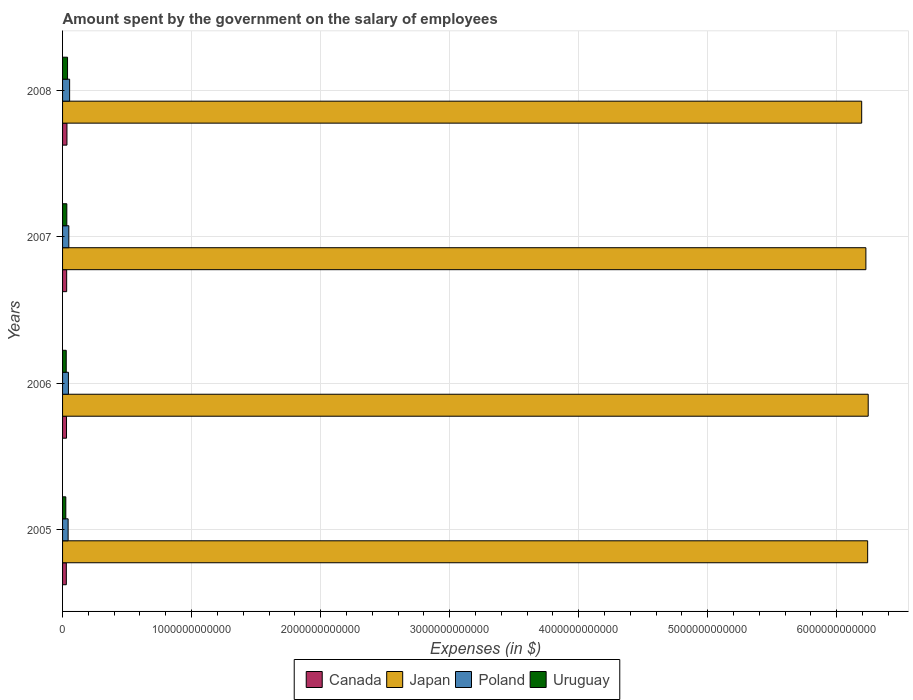How many different coloured bars are there?
Your response must be concise. 4. How many groups of bars are there?
Offer a very short reply. 4. Are the number of bars per tick equal to the number of legend labels?
Provide a succinct answer. Yes. Are the number of bars on each tick of the Y-axis equal?
Your answer should be compact. Yes. How many bars are there on the 3rd tick from the top?
Keep it short and to the point. 4. How many bars are there on the 4th tick from the bottom?
Give a very brief answer. 4. In how many cases, is the number of bars for a given year not equal to the number of legend labels?
Your answer should be compact. 0. What is the amount spent on the salary of employees by the government in Uruguay in 2006?
Offer a very short reply. 2.84e+1. Across all years, what is the maximum amount spent on the salary of employees by the government in Japan?
Your answer should be very brief. 6.24e+12. Across all years, what is the minimum amount spent on the salary of employees by the government in Canada?
Give a very brief answer. 2.92e+1. What is the total amount spent on the salary of employees by the government in Japan in the graph?
Give a very brief answer. 2.49e+13. What is the difference between the amount spent on the salary of employees by the government in Uruguay in 2005 and that in 2008?
Your answer should be very brief. -1.33e+1. What is the difference between the amount spent on the salary of employees by the government in Canada in 2005 and the amount spent on the salary of employees by the government in Japan in 2008?
Provide a succinct answer. -6.16e+12. What is the average amount spent on the salary of employees by the government in Uruguay per year?
Your answer should be compact. 3.13e+1. In the year 2006, what is the difference between the amount spent on the salary of employees by the government in Poland and amount spent on the salary of employees by the government in Canada?
Your answer should be very brief. 1.48e+1. In how many years, is the amount spent on the salary of employees by the government in Uruguay greater than 2600000000000 $?
Ensure brevity in your answer.  0. What is the ratio of the amount spent on the salary of employees by the government in Canada in 2006 to that in 2007?
Offer a terse response. 0.96. What is the difference between the highest and the second highest amount spent on the salary of employees by the government in Japan?
Make the answer very short. 4.30e+09. What is the difference between the highest and the lowest amount spent on the salary of employees by the government in Japan?
Your answer should be compact. 5.06e+1. What does the 3rd bar from the top in 2007 represents?
Ensure brevity in your answer.  Japan. What does the 4th bar from the bottom in 2005 represents?
Your response must be concise. Uruguay. Are all the bars in the graph horizontal?
Offer a terse response. Yes. How many years are there in the graph?
Your response must be concise. 4. What is the difference between two consecutive major ticks on the X-axis?
Provide a short and direct response. 1.00e+12. Are the values on the major ticks of X-axis written in scientific E-notation?
Offer a terse response. No. How are the legend labels stacked?
Keep it short and to the point. Horizontal. What is the title of the graph?
Offer a terse response. Amount spent by the government on the salary of employees. What is the label or title of the X-axis?
Give a very brief answer. Expenses (in $). What is the Expenses (in $) of Canada in 2005?
Provide a short and direct response. 2.92e+1. What is the Expenses (in $) in Japan in 2005?
Offer a terse response. 6.24e+12. What is the Expenses (in $) in Poland in 2005?
Your answer should be very brief. 4.31e+1. What is the Expenses (in $) in Uruguay in 2005?
Your answer should be very brief. 2.52e+1. What is the Expenses (in $) of Canada in 2006?
Provide a short and direct response. 3.06e+1. What is the Expenses (in $) in Japan in 2006?
Make the answer very short. 6.24e+12. What is the Expenses (in $) in Poland in 2006?
Keep it short and to the point. 4.54e+1. What is the Expenses (in $) in Uruguay in 2006?
Your response must be concise. 2.84e+1. What is the Expenses (in $) of Canada in 2007?
Provide a succinct answer. 3.18e+1. What is the Expenses (in $) in Japan in 2007?
Ensure brevity in your answer.  6.23e+12. What is the Expenses (in $) in Poland in 2007?
Ensure brevity in your answer.  4.85e+1. What is the Expenses (in $) of Uruguay in 2007?
Your answer should be very brief. 3.30e+1. What is the Expenses (in $) of Canada in 2008?
Your response must be concise. 3.40e+1. What is the Expenses (in $) of Japan in 2008?
Make the answer very short. 6.19e+12. What is the Expenses (in $) of Poland in 2008?
Your answer should be compact. 5.47e+1. What is the Expenses (in $) of Uruguay in 2008?
Provide a short and direct response. 3.86e+1. Across all years, what is the maximum Expenses (in $) of Canada?
Offer a very short reply. 3.40e+1. Across all years, what is the maximum Expenses (in $) in Japan?
Your response must be concise. 6.24e+12. Across all years, what is the maximum Expenses (in $) of Poland?
Keep it short and to the point. 5.47e+1. Across all years, what is the maximum Expenses (in $) in Uruguay?
Ensure brevity in your answer.  3.86e+1. Across all years, what is the minimum Expenses (in $) in Canada?
Keep it short and to the point. 2.92e+1. Across all years, what is the minimum Expenses (in $) of Japan?
Make the answer very short. 6.19e+12. Across all years, what is the minimum Expenses (in $) of Poland?
Provide a short and direct response. 4.31e+1. Across all years, what is the minimum Expenses (in $) of Uruguay?
Ensure brevity in your answer.  2.52e+1. What is the total Expenses (in $) of Canada in the graph?
Offer a terse response. 1.26e+11. What is the total Expenses (in $) in Japan in the graph?
Your answer should be very brief. 2.49e+13. What is the total Expenses (in $) in Poland in the graph?
Your response must be concise. 1.92e+11. What is the total Expenses (in $) in Uruguay in the graph?
Provide a short and direct response. 1.25e+11. What is the difference between the Expenses (in $) in Canada in 2005 and that in 2006?
Offer a very short reply. -1.36e+09. What is the difference between the Expenses (in $) of Japan in 2005 and that in 2006?
Offer a very short reply. -4.30e+09. What is the difference between the Expenses (in $) of Poland in 2005 and that in 2006?
Make the answer very short. -2.33e+09. What is the difference between the Expenses (in $) of Uruguay in 2005 and that in 2006?
Provide a succinct answer. -3.24e+09. What is the difference between the Expenses (in $) of Canada in 2005 and that in 2007?
Keep it short and to the point. -2.63e+09. What is the difference between the Expenses (in $) of Japan in 2005 and that in 2007?
Offer a terse response. 1.37e+1. What is the difference between the Expenses (in $) in Poland in 2005 and that in 2007?
Ensure brevity in your answer.  -5.40e+09. What is the difference between the Expenses (in $) of Uruguay in 2005 and that in 2007?
Provide a short and direct response. -7.79e+09. What is the difference between the Expenses (in $) in Canada in 2005 and that in 2008?
Your response must be concise. -4.74e+09. What is the difference between the Expenses (in $) of Japan in 2005 and that in 2008?
Keep it short and to the point. 4.63e+1. What is the difference between the Expenses (in $) in Poland in 2005 and that in 2008?
Your answer should be very brief. -1.16e+1. What is the difference between the Expenses (in $) of Uruguay in 2005 and that in 2008?
Keep it short and to the point. -1.33e+1. What is the difference between the Expenses (in $) of Canada in 2006 and that in 2007?
Provide a short and direct response. -1.27e+09. What is the difference between the Expenses (in $) of Japan in 2006 and that in 2007?
Your answer should be very brief. 1.80e+1. What is the difference between the Expenses (in $) of Poland in 2006 and that in 2007?
Give a very brief answer. -3.07e+09. What is the difference between the Expenses (in $) in Uruguay in 2006 and that in 2007?
Provide a short and direct response. -4.56e+09. What is the difference between the Expenses (in $) in Canada in 2006 and that in 2008?
Ensure brevity in your answer.  -3.38e+09. What is the difference between the Expenses (in $) of Japan in 2006 and that in 2008?
Your response must be concise. 5.06e+1. What is the difference between the Expenses (in $) in Poland in 2006 and that in 2008?
Offer a very short reply. -9.30e+09. What is the difference between the Expenses (in $) in Uruguay in 2006 and that in 2008?
Keep it short and to the point. -1.01e+1. What is the difference between the Expenses (in $) of Canada in 2007 and that in 2008?
Provide a short and direct response. -2.11e+09. What is the difference between the Expenses (in $) of Japan in 2007 and that in 2008?
Provide a short and direct response. 3.26e+1. What is the difference between the Expenses (in $) in Poland in 2007 and that in 2008?
Your answer should be compact. -6.23e+09. What is the difference between the Expenses (in $) in Uruguay in 2007 and that in 2008?
Provide a succinct answer. -5.55e+09. What is the difference between the Expenses (in $) of Canada in 2005 and the Expenses (in $) of Japan in 2006?
Your response must be concise. -6.21e+12. What is the difference between the Expenses (in $) in Canada in 2005 and the Expenses (in $) in Poland in 2006?
Provide a short and direct response. -1.62e+1. What is the difference between the Expenses (in $) of Canada in 2005 and the Expenses (in $) of Uruguay in 2006?
Provide a succinct answer. 7.65e+08. What is the difference between the Expenses (in $) of Japan in 2005 and the Expenses (in $) of Poland in 2006?
Your answer should be compact. 6.19e+12. What is the difference between the Expenses (in $) in Japan in 2005 and the Expenses (in $) in Uruguay in 2006?
Give a very brief answer. 6.21e+12. What is the difference between the Expenses (in $) in Poland in 2005 and the Expenses (in $) in Uruguay in 2006?
Provide a succinct answer. 1.46e+1. What is the difference between the Expenses (in $) in Canada in 2005 and the Expenses (in $) in Japan in 2007?
Your answer should be very brief. -6.20e+12. What is the difference between the Expenses (in $) of Canada in 2005 and the Expenses (in $) of Poland in 2007?
Provide a succinct answer. -1.93e+1. What is the difference between the Expenses (in $) in Canada in 2005 and the Expenses (in $) in Uruguay in 2007?
Make the answer very short. -3.79e+09. What is the difference between the Expenses (in $) of Japan in 2005 and the Expenses (in $) of Poland in 2007?
Your answer should be compact. 6.19e+12. What is the difference between the Expenses (in $) in Japan in 2005 and the Expenses (in $) in Uruguay in 2007?
Your response must be concise. 6.21e+12. What is the difference between the Expenses (in $) in Poland in 2005 and the Expenses (in $) in Uruguay in 2007?
Provide a short and direct response. 1.01e+1. What is the difference between the Expenses (in $) in Canada in 2005 and the Expenses (in $) in Japan in 2008?
Ensure brevity in your answer.  -6.16e+12. What is the difference between the Expenses (in $) in Canada in 2005 and the Expenses (in $) in Poland in 2008?
Offer a very short reply. -2.55e+1. What is the difference between the Expenses (in $) of Canada in 2005 and the Expenses (in $) of Uruguay in 2008?
Ensure brevity in your answer.  -9.35e+09. What is the difference between the Expenses (in $) of Japan in 2005 and the Expenses (in $) of Poland in 2008?
Offer a very short reply. 6.18e+12. What is the difference between the Expenses (in $) of Japan in 2005 and the Expenses (in $) of Uruguay in 2008?
Provide a short and direct response. 6.20e+12. What is the difference between the Expenses (in $) in Poland in 2005 and the Expenses (in $) in Uruguay in 2008?
Ensure brevity in your answer.  4.53e+09. What is the difference between the Expenses (in $) in Canada in 2006 and the Expenses (in $) in Japan in 2007?
Give a very brief answer. -6.20e+12. What is the difference between the Expenses (in $) of Canada in 2006 and the Expenses (in $) of Poland in 2007?
Ensure brevity in your answer.  -1.79e+1. What is the difference between the Expenses (in $) of Canada in 2006 and the Expenses (in $) of Uruguay in 2007?
Your response must be concise. -2.43e+09. What is the difference between the Expenses (in $) of Japan in 2006 and the Expenses (in $) of Poland in 2007?
Provide a short and direct response. 6.20e+12. What is the difference between the Expenses (in $) in Japan in 2006 and the Expenses (in $) in Uruguay in 2007?
Ensure brevity in your answer.  6.21e+12. What is the difference between the Expenses (in $) of Poland in 2006 and the Expenses (in $) of Uruguay in 2007?
Provide a short and direct response. 1.24e+1. What is the difference between the Expenses (in $) of Canada in 2006 and the Expenses (in $) of Japan in 2008?
Keep it short and to the point. -6.16e+12. What is the difference between the Expenses (in $) of Canada in 2006 and the Expenses (in $) of Poland in 2008?
Your answer should be very brief. -2.41e+1. What is the difference between the Expenses (in $) of Canada in 2006 and the Expenses (in $) of Uruguay in 2008?
Your answer should be very brief. -7.99e+09. What is the difference between the Expenses (in $) in Japan in 2006 and the Expenses (in $) in Poland in 2008?
Offer a very short reply. 6.19e+12. What is the difference between the Expenses (in $) in Japan in 2006 and the Expenses (in $) in Uruguay in 2008?
Your response must be concise. 6.21e+12. What is the difference between the Expenses (in $) in Poland in 2006 and the Expenses (in $) in Uruguay in 2008?
Provide a succinct answer. 6.86e+09. What is the difference between the Expenses (in $) in Canada in 2007 and the Expenses (in $) in Japan in 2008?
Keep it short and to the point. -6.16e+12. What is the difference between the Expenses (in $) of Canada in 2007 and the Expenses (in $) of Poland in 2008?
Offer a terse response. -2.29e+1. What is the difference between the Expenses (in $) in Canada in 2007 and the Expenses (in $) in Uruguay in 2008?
Keep it short and to the point. -6.71e+09. What is the difference between the Expenses (in $) in Japan in 2007 and the Expenses (in $) in Poland in 2008?
Make the answer very short. 6.17e+12. What is the difference between the Expenses (in $) of Japan in 2007 and the Expenses (in $) of Uruguay in 2008?
Offer a terse response. 6.19e+12. What is the difference between the Expenses (in $) in Poland in 2007 and the Expenses (in $) in Uruguay in 2008?
Offer a very short reply. 9.93e+09. What is the average Expenses (in $) of Canada per year?
Offer a very short reply. 3.14e+1. What is the average Expenses (in $) in Japan per year?
Your response must be concise. 6.23e+12. What is the average Expenses (in $) in Poland per year?
Offer a very short reply. 4.79e+1. What is the average Expenses (in $) in Uruguay per year?
Ensure brevity in your answer.  3.13e+1. In the year 2005, what is the difference between the Expenses (in $) in Canada and Expenses (in $) in Japan?
Offer a terse response. -6.21e+12. In the year 2005, what is the difference between the Expenses (in $) of Canada and Expenses (in $) of Poland?
Ensure brevity in your answer.  -1.39e+1. In the year 2005, what is the difference between the Expenses (in $) of Canada and Expenses (in $) of Uruguay?
Your answer should be compact. 4.00e+09. In the year 2005, what is the difference between the Expenses (in $) in Japan and Expenses (in $) in Poland?
Make the answer very short. 6.20e+12. In the year 2005, what is the difference between the Expenses (in $) in Japan and Expenses (in $) in Uruguay?
Your response must be concise. 6.21e+12. In the year 2005, what is the difference between the Expenses (in $) of Poland and Expenses (in $) of Uruguay?
Your response must be concise. 1.79e+1. In the year 2006, what is the difference between the Expenses (in $) of Canada and Expenses (in $) of Japan?
Your response must be concise. -6.21e+12. In the year 2006, what is the difference between the Expenses (in $) in Canada and Expenses (in $) in Poland?
Provide a succinct answer. -1.48e+1. In the year 2006, what is the difference between the Expenses (in $) in Canada and Expenses (in $) in Uruguay?
Your answer should be very brief. 2.12e+09. In the year 2006, what is the difference between the Expenses (in $) of Japan and Expenses (in $) of Poland?
Give a very brief answer. 6.20e+12. In the year 2006, what is the difference between the Expenses (in $) in Japan and Expenses (in $) in Uruguay?
Your answer should be compact. 6.22e+12. In the year 2006, what is the difference between the Expenses (in $) of Poland and Expenses (in $) of Uruguay?
Offer a terse response. 1.70e+1. In the year 2007, what is the difference between the Expenses (in $) of Canada and Expenses (in $) of Japan?
Your answer should be compact. -6.19e+12. In the year 2007, what is the difference between the Expenses (in $) in Canada and Expenses (in $) in Poland?
Provide a short and direct response. -1.66e+1. In the year 2007, what is the difference between the Expenses (in $) in Canada and Expenses (in $) in Uruguay?
Your answer should be very brief. -1.16e+09. In the year 2007, what is the difference between the Expenses (in $) of Japan and Expenses (in $) of Poland?
Keep it short and to the point. 6.18e+12. In the year 2007, what is the difference between the Expenses (in $) of Japan and Expenses (in $) of Uruguay?
Offer a very short reply. 6.19e+12. In the year 2007, what is the difference between the Expenses (in $) in Poland and Expenses (in $) in Uruguay?
Ensure brevity in your answer.  1.55e+1. In the year 2008, what is the difference between the Expenses (in $) of Canada and Expenses (in $) of Japan?
Make the answer very short. -6.16e+12. In the year 2008, what is the difference between the Expenses (in $) in Canada and Expenses (in $) in Poland?
Your answer should be very brief. -2.08e+1. In the year 2008, what is the difference between the Expenses (in $) of Canada and Expenses (in $) of Uruguay?
Your answer should be very brief. -4.61e+09. In the year 2008, what is the difference between the Expenses (in $) in Japan and Expenses (in $) in Poland?
Give a very brief answer. 6.14e+12. In the year 2008, what is the difference between the Expenses (in $) in Japan and Expenses (in $) in Uruguay?
Keep it short and to the point. 6.15e+12. In the year 2008, what is the difference between the Expenses (in $) in Poland and Expenses (in $) in Uruguay?
Your response must be concise. 1.62e+1. What is the ratio of the Expenses (in $) in Canada in 2005 to that in 2006?
Offer a terse response. 0.96. What is the ratio of the Expenses (in $) in Japan in 2005 to that in 2006?
Offer a terse response. 1. What is the ratio of the Expenses (in $) in Poland in 2005 to that in 2006?
Provide a short and direct response. 0.95. What is the ratio of the Expenses (in $) in Uruguay in 2005 to that in 2006?
Offer a terse response. 0.89. What is the ratio of the Expenses (in $) in Canada in 2005 to that in 2007?
Your answer should be very brief. 0.92. What is the ratio of the Expenses (in $) of Poland in 2005 to that in 2007?
Your answer should be very brief. 0.89. What is the ratio of the Expenses (in $) in Uruguay in 2005 to that in 2007?
Ensure brevity in your answer.  0.76. What is the ratio of the Expenses (in $) in Canada in 2005 to that in 2008?
Your answer should be very brief. 0.86. What is the ratio of the Expenses (in $) of Japan in 2005 to that in 2008?
Offer a terse response. 1.01. What is the ratio of the Expenses (in $) of Poland in 2005 to that in 2008?
Ensure brevity in your answer.  0.79. What is the ratio of the Expenses (in $) in Uruguay in 2005 to that in 2008?
Make the answer very short. 0.65. What is the ratio of the Expenses (in $) of Canada in 2006 to that in 2007?
Your answer should be compact. 0.96. What is the ratio of the Expenses (in $) of Japan in 2006 to that in 2007?
Offer a terse response. 1. What is the ratio of the Expenses (in $) of Poland in 2006 to that in 2007?
Make the answer very short. 0.94. What is the ratio of the Expenses (in $) of Uruguay in 2006 to that in 2007?
Provide a succinct answer. 0.86. What is the ratio of the Expenses (in $) of Canada in 2006 to that in 2008?
Offer a terse response. 0.9. What is the ratio of the Expenses (in $) of Japan in 2006 to that in 2008?
Keep it short and to the point. 1.01. What is the ratio of the Expenses (in $) of Poland in 2006 to that in 2008?
Give a very brief answer. 0.83. What is the ratio of the Expenses (in $) in Uruguay in 2006 to that in 2008?
Your response must be concise. 0.74. What is the ratio of the Expenses (in $) in Canada in 2007 to that in 2008?
Your answer should be very brief. 0.94. What is the ratio of the Expenses (in $) of Poland in 2007 to that in 2008?
Give a very brief answer. 0.89. What is the ratio of the Expenses (in $) in Uruguay in 2007 to that in 2008?
Make the answer very short. 0.86. What is the difference between the highest and the second highest Expenses (in $) of Canada?
Offer a very short reply. 2.11e+09. What is the difference between the highest and the second highest Expenses (in $) of Japan?
Provide a succinct answer. 4.30e+09. What is the difference between the highest and the second highest Expenses (in $) of Poland?
Offer a very short reply. 6.23e+09. What is the difference between the highest and the second highest Expenses (in $) in Uruguay?
Offer a very short reply. 5.55e+09. What is the difference between the highest and the lowest Expenses (in $) of Canada?
Your response must be concise. 4.74e+09. What is the difference between the highest and the lowest Expenses (in $) of Japan?
Your response must be concise. 5.06e+1. What is the difference between the highest and the lowest Expenses (in $) in Poland?
Make the answer very short. 1.16e+1. What is the difference between the highest and the lowest Expenses (in $) of Uruguay?
Ensure brevity in your answer.  1.33e+1. 